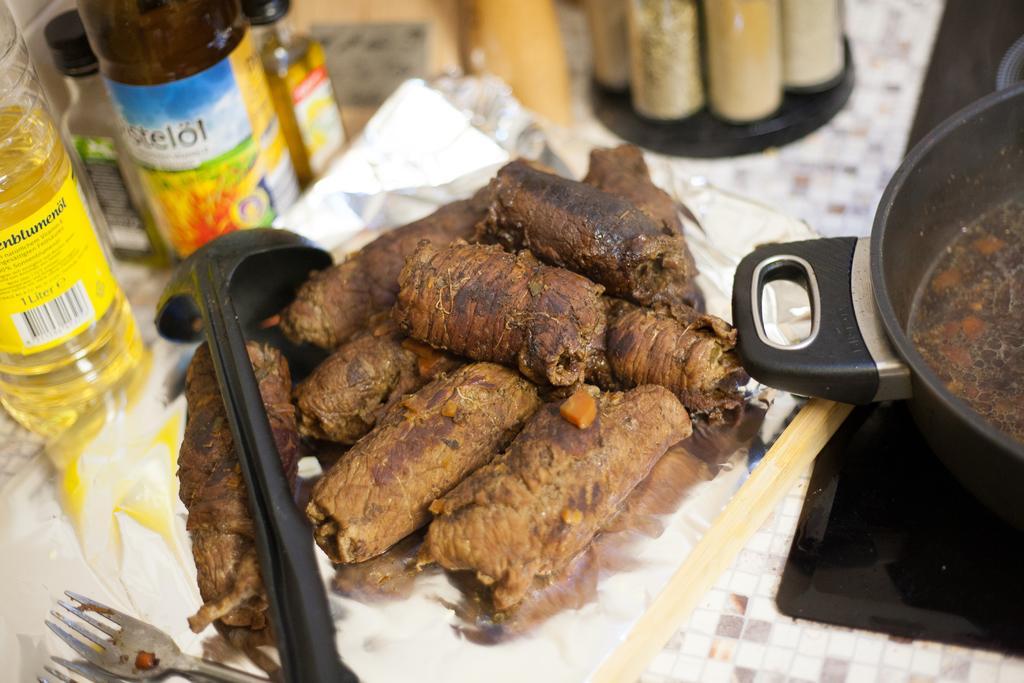Could you give a brief overview of what you see in this image? In this image we can see food item and few objects on a surface. 